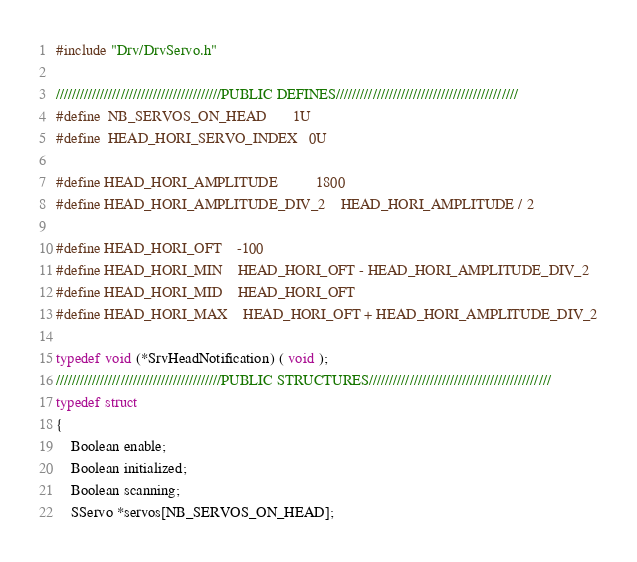<code> <loc_0><loc_0><loc_500><loc_500><_C_>
#include "Drv/DrvServo.h"

/////////////////////////////////////////PUBLIC DEFINES/////////////////////////////////////////////
#define	NB_SERVOS_ON_HEAD		1U
#define	HEAD_HORI_SERVO_INDEX	0U

#define HEAD_HORI_AMPLITUDE			1800
#define HEAD_HORI_AMPLITUDE_DIV_2	HEAD_HORI_AMPLITUDE / 2

#define HEAD_HORI_OFT	-100
#define HEAD_HORI_MIN	HEAD_HORI_OFT - HEAD_HORI_AMPLITUDE_DIV_2
#define HEAD_HORI_MID	HEAD_HORI_OFT
#define HEAD_HORI_MAX	HEAD_HORI_OFT + HEAD_HORI_AMPLITUDE_DIV_2

typedef void (*SrvHeadNotification) ( void );
/////////////////////////////////////////PUBLIC STRUCTURES/////////////////////////////////////////////
typedef struct
{
	Boolean enable;
	Boolean initialized;
	Boolean scanning;
	SServo *servos[NB_SERVOS_ON_HEAD];</code> 